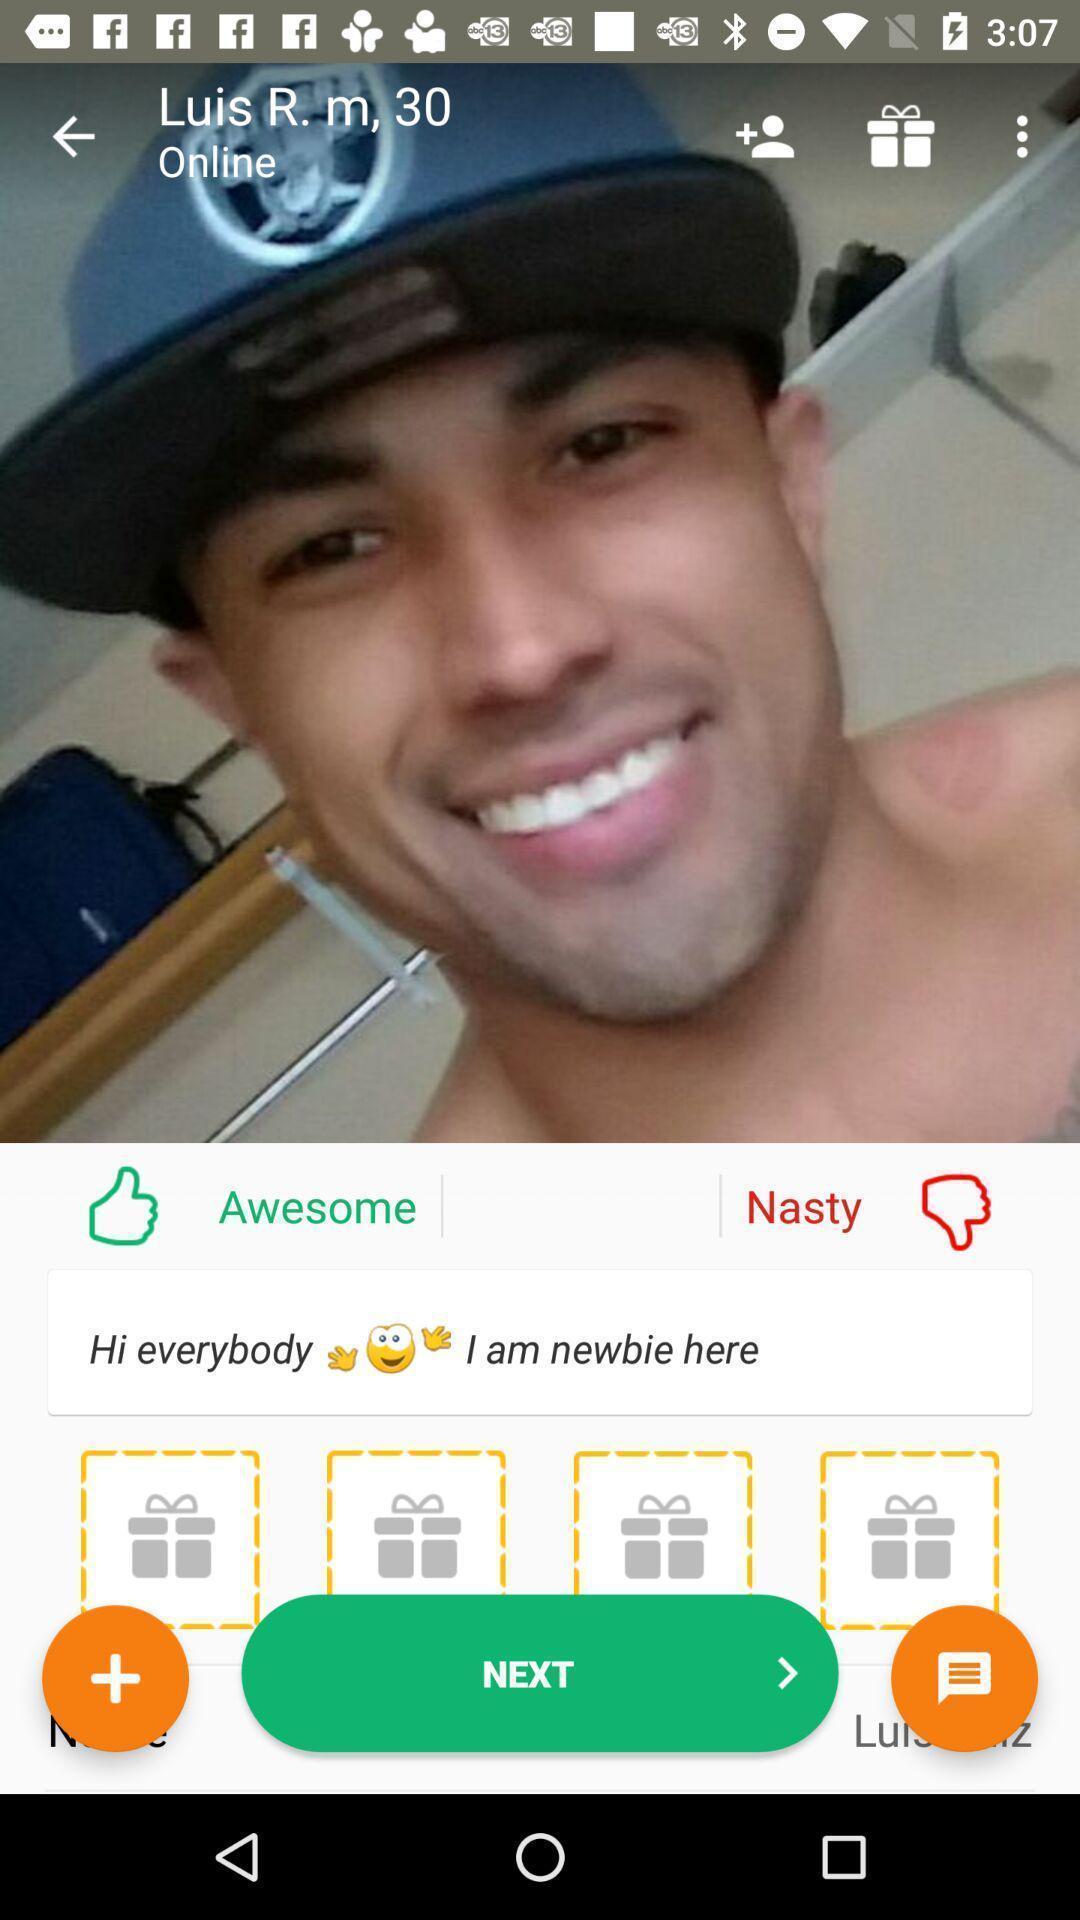Provide a description of this screenshot. Profile picture of user showing online. 